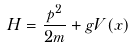<formula> <loc_0><loc_0><loc_500><loc_500>H = \frac { p ^ { 2 } } { 2 m } + g V ( x )</formula> 